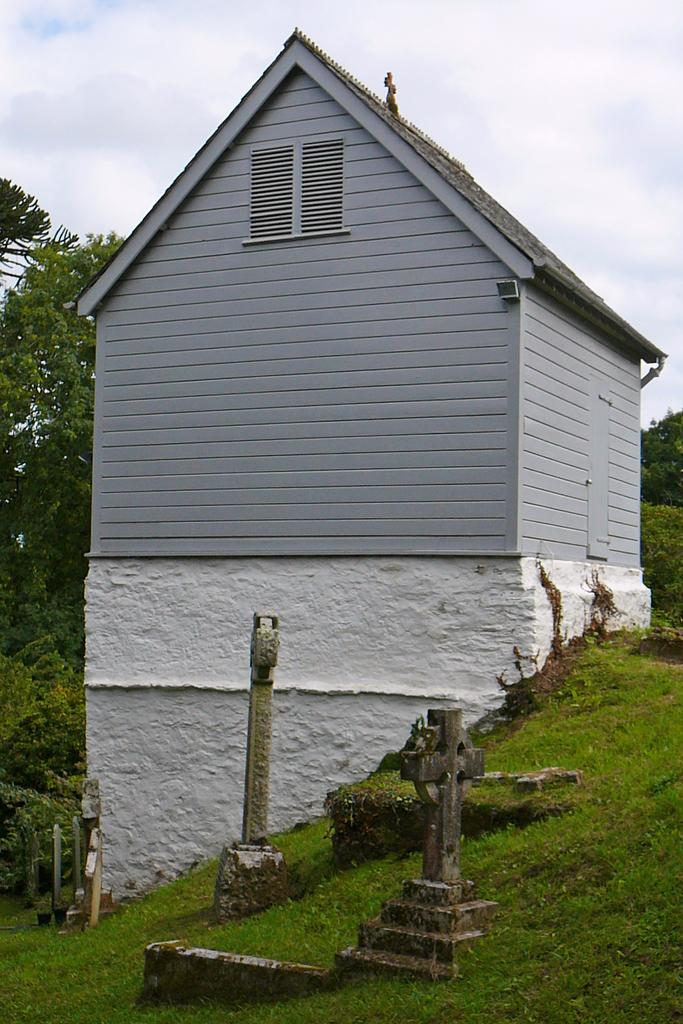What type of structure can be seen in the image? There is a shed in the image. What type of vegetation is present in the image? There is grass in the image. What other natural elements can be seen in the image? There are trees in the image. What else can be found in the image besides the shed and vegetation? There are objects in the image. What is visible in the background of the image? The sky is visible in the background of the image. Can you describe the sky in the image? Clouds are present in the sky. How does the shed breathe in the image? Sheds do not breathe, as they are inanimate objects. 